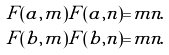Convert formula to latex. <formula><loc_0><loc_0><loc_500><loc_500>F ( a , m ) F ( a , n ) = & m n . \\ F ( b , m ) F ( b , n ) = & m n .</formula> 